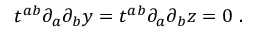Convert formula to latex. <formula><loc_0><loc_0><loc_500><loc_500>t ^ { a b } \partial _ { a } \partial _ { b } y = t ^ { a b } \partial _ { a } \partial _ { b } z = 0 \ .</formula> 